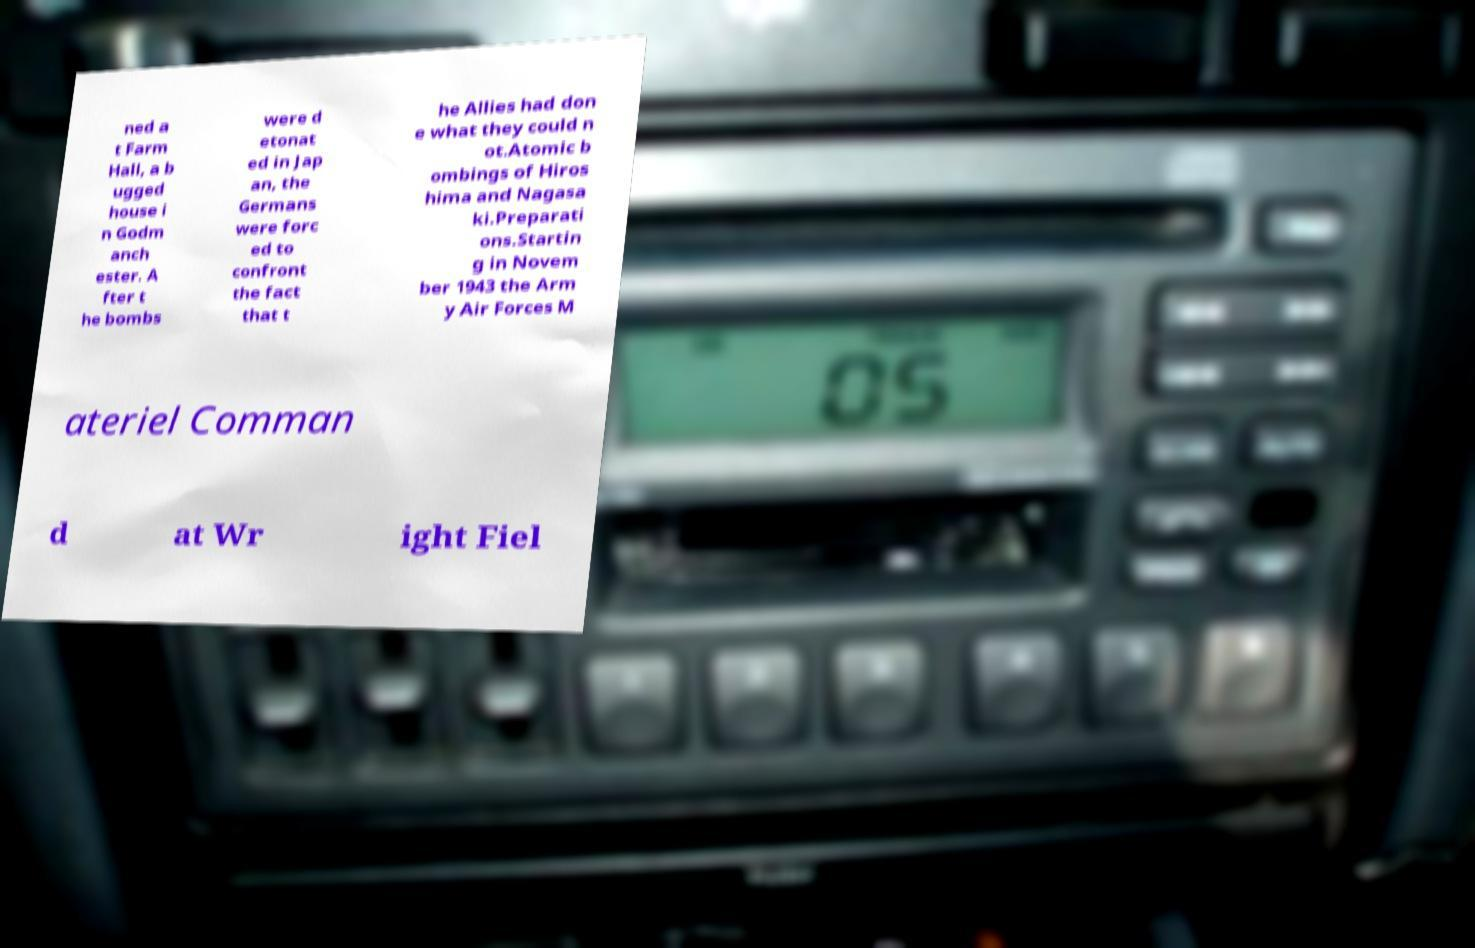There's text embedded in this image that I need extracted. Can you transcribe it verbatim? ned a t Farm Hall, a b ugged house i n Godm anch ester. A fter t he bombs were d etonat ed in Jap an, the Germans were forc ed to confront the fact that t he Allies had don e what they could n ot.Atomic b ombings of Hiros hima and Nagasa ki.Preparati ons.Startin g in Novem ber 1943 the Arm y Air Forces M ateriel Comman d at Wr ight Fiel 